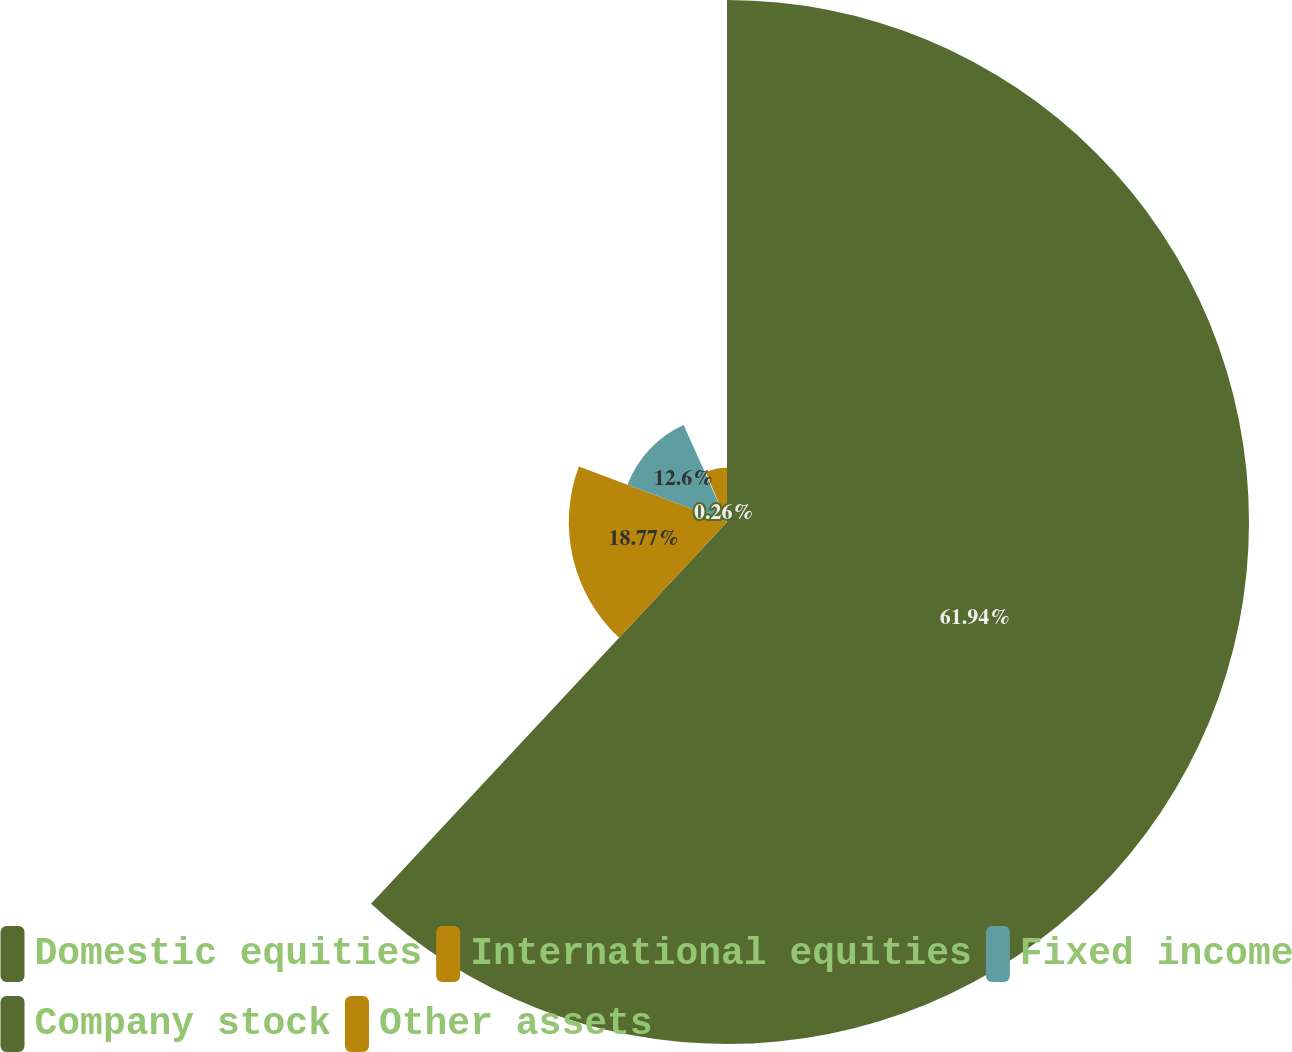Convert chart to OTSL. <chart><loc_0><loc_0><loc_500><loc_500><pie_chart><fcel>Domestic equities<fcel>International equities<fcel>Fixed income<fcel>Company stock<fcel>Other assets<nl><fcel>61.94%<fcel>18.77%<fcel>12.6%<fcel>0.26%<fcel>6.43%<nl></chart> 